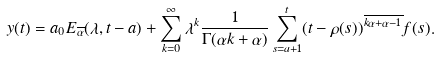<formula> <loc_0><loc_0><loc_500><loc_500>y ( t ) = a _ { 0 } E _ { \overline { \alpha } } ( \lambda , t - a ) + \sum _ { k = 0 } ^ { \infty } \lambda ^ { k } \frac { 1 } { \Gamma ( \alpha k + \alpha ) } \sum _ { s = a + 1 } ^ { t } ( t - \rho ( s ) ) ^ { \overline { k \alpha + \alpha - 1 } } f ( s ) .</formula> 